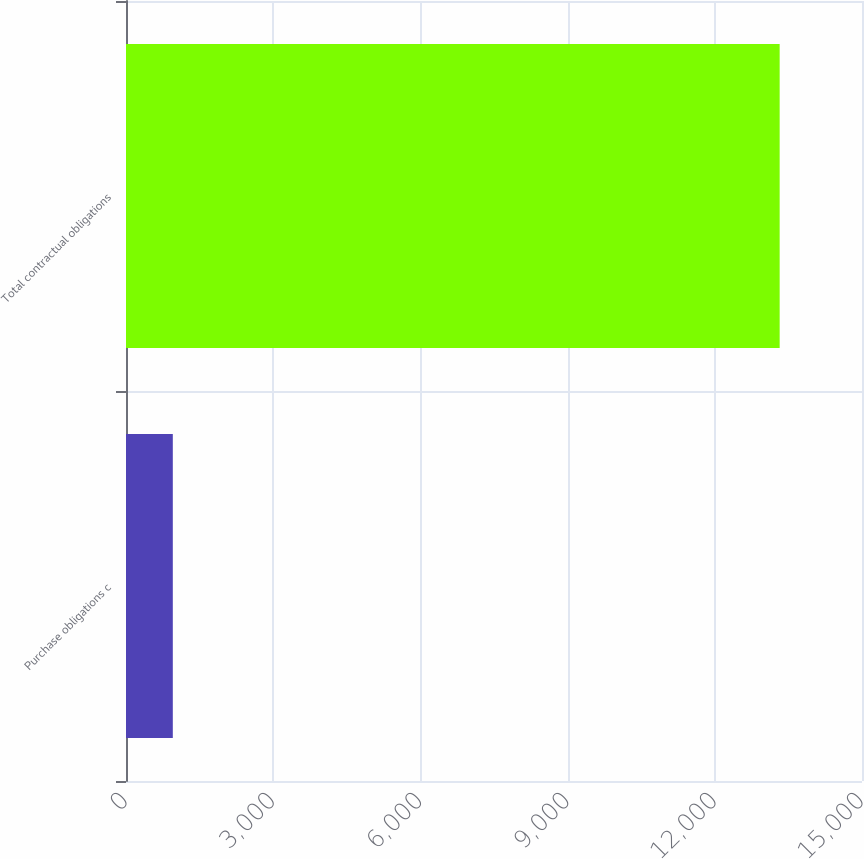<chart> <loc_0><loc_0><loc_500><loc_500><bar_chart><fcel>Purchase obligations c<fcel>Total contractual obligations<nl><fcel>954<fcel>13322<nl></chart> 